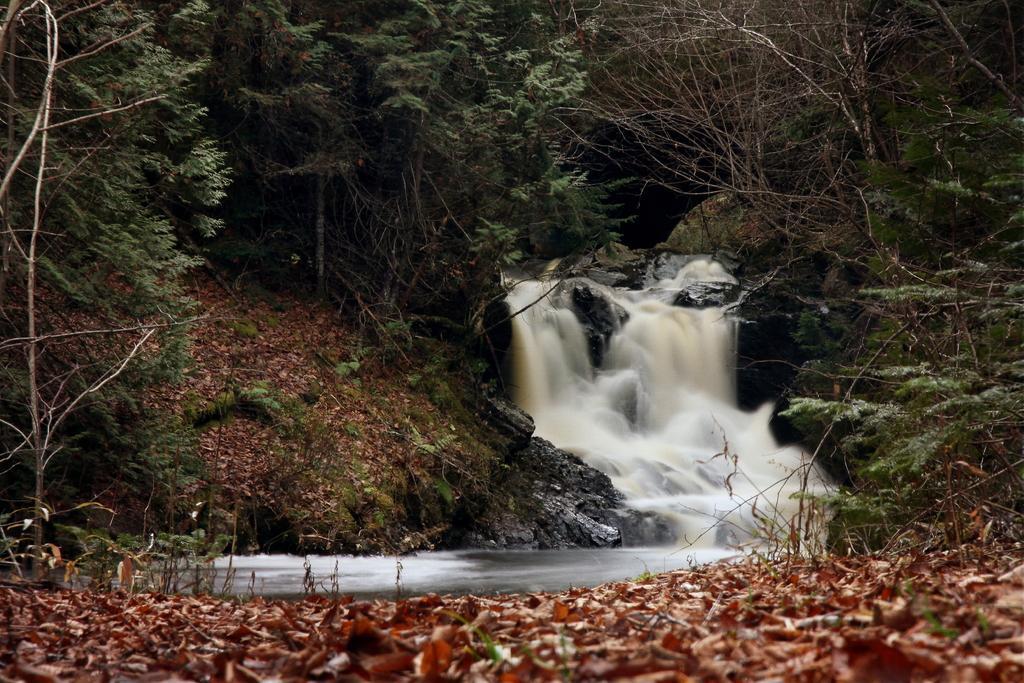Please provide a concise description of this image. We can see leaves, water and trees. 